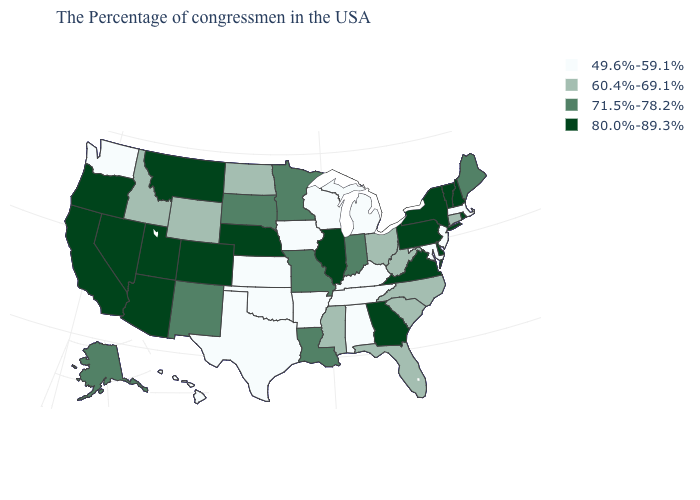Is the legend a continuous bar?
Quick response, please. No. What is the value of South Dakota?
Keep it brief. 71.5%-78.2%. Among the states that border Utah , which have the highest value?
Give a very brief answer. Colorado, Arizona, Nevada. Name the states that have a value in the range 60.4%-69.1%?
Write a very short answer. Connecticut, North Carolina, South Carolina, West Virginia, Ohio, Florida, Mississippi, North Dakota, Wyoming, Idaho. What is the value of Nevada?
Keep it brief. 80.0%-89.3%. What is the highest value in the South ?
Concise answer only. 80.0%-89.3%. Name the states that have a value in the range 60.4%-69.1%?
Concise answer only. Connecticut, North Carolina, South Carolina, West Virginia, Ohio, Florida, Mississippi, North Dakota, Wyoming, Idaho. What is the value of Idaho?
Give a very brief answer. 60.4%-69.1%. Which states have the highest value in the USA?
Keep it brief. Rhode Island, New Hampshire, Vermont, New York, Delaware, Pennsylvania, Virginia, Georgia, Illinois, Nebraska, Colorado, Utah, Montana, Arizona, Nevada, California, Oregon. Name the states that have a value in the range 80.0%-89.3%?
Be succinct. Rhode Island, New Hampshire, Vermont, New York, Delaware, Pennsylvania, Virginia, Georgia, Illinois, Nebraska, Colorado, Utah, Montana, Arizona, Nevada, California, Oregon. What is the highest value in states that border Connecticut?
Answer briefly. 80.0%-89.3%. Does Colorado have the highest value in the West?
Short answer required. Yes. What is the highest value in states that border Arizona?
Answer briefly. 80.0%-89.3%. What is the value of California?
Short answer required. 80.0%-89.3%. Does Montana have the highest value in the West?
Concise answer only. Yes. 